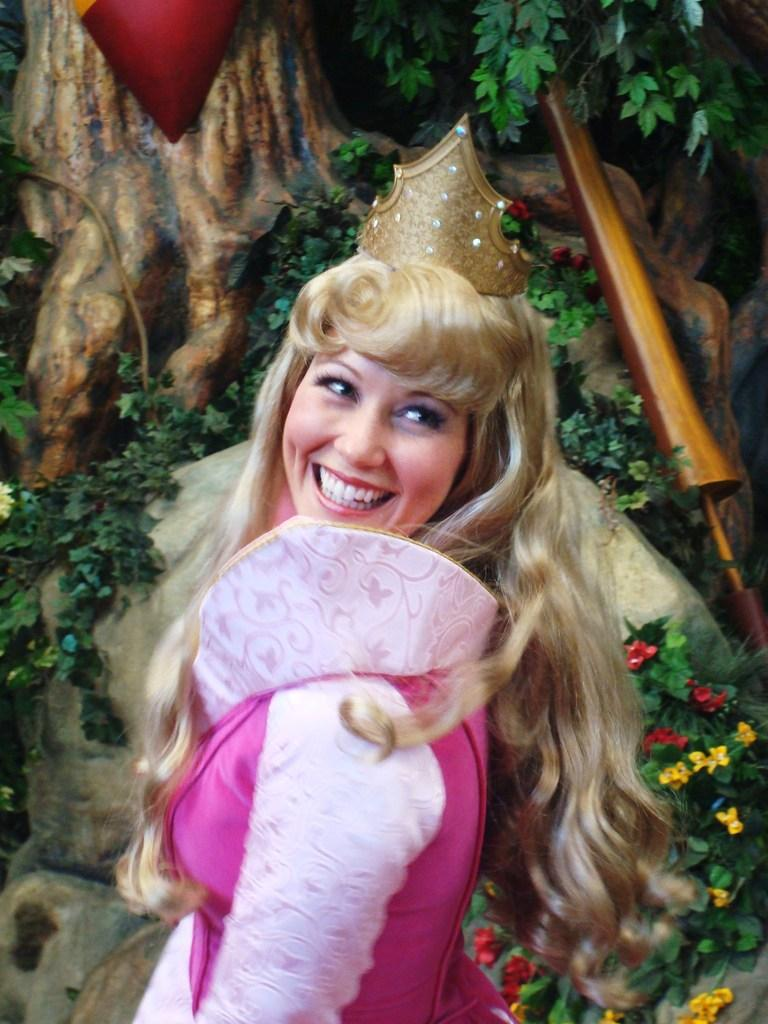Who is the main subject in the image? There is a girl in the image. What is the girl wearing? The girl is wearing a pink dress and a crown. What can be seen in the background of the image? There are plants and rocks in the background of the image. What type of hook is the girl using to hold onto the sign in the image? There is no hook or sign present in the image; the girl is simply wearing a crown and standing in front of plants and rocks. 